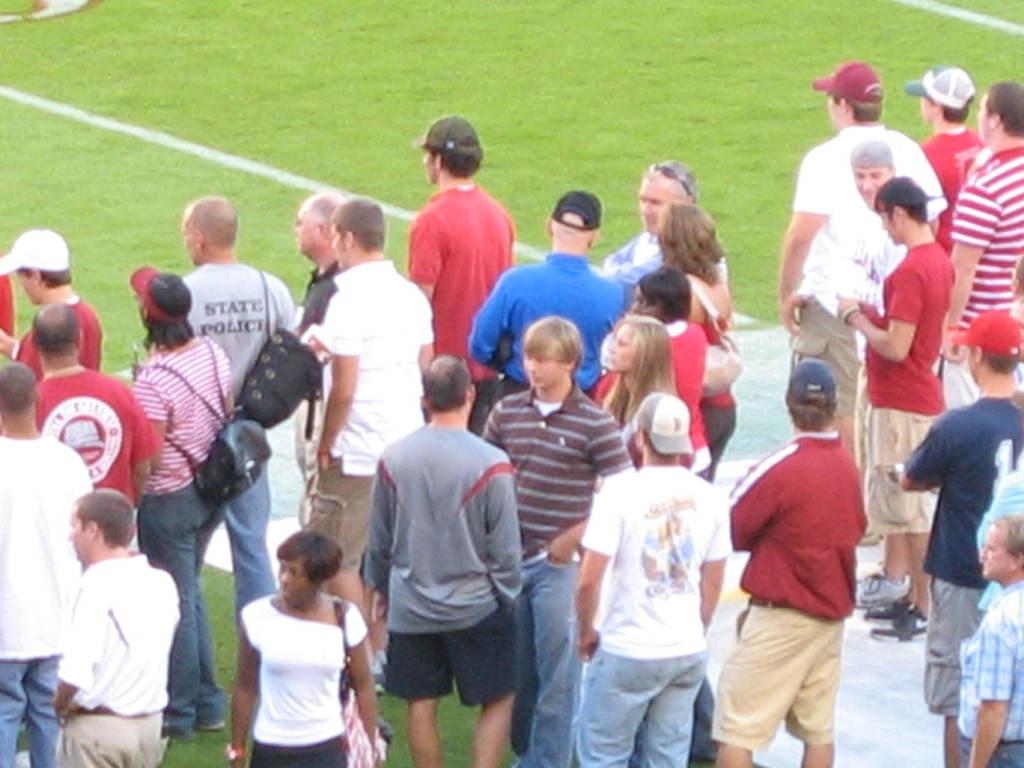What can be seen in the image in terms of living beings? There are people standing in the image. What type of environment is visible in the image? There is a grassland in the image. Where is the nest located in the image? There is no nest present in the image. What type of floor can be seen in the image? The image does not show a floor, as it features people standing on a grassland. 